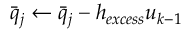<formula> <loc_0><loc_0><loc_500><loc_500>\bar { q } _ { j } \leftarrow \bar { q } _ { j } - h _ { e x c e s s } u _ { k - 1 }</formula> 